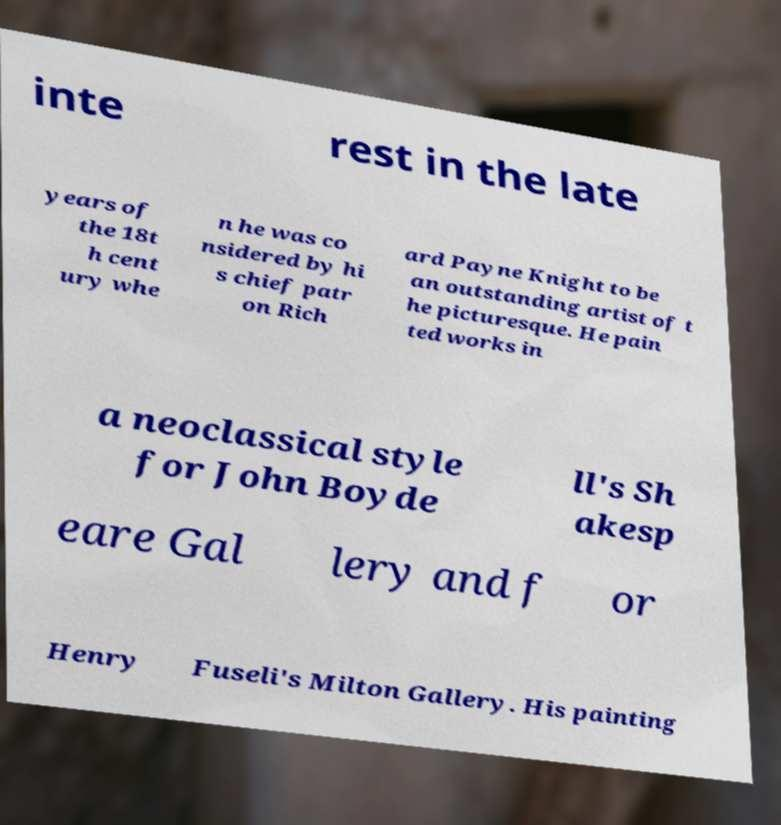For documentation purposes, I need the text within this image transcribed. Could you provide that? inte rest in the late years of the 18t h cent ury whe n he was co nsidered by hi s chief patr on Rich ard Payne Knight to be an outstanding artist of t he picturesque. He pain ted works in a neoclassical style for John Boyde ll's Sh akesp eare Gal lery and f or Henry Fuseli's Milton Gallery. His painting 